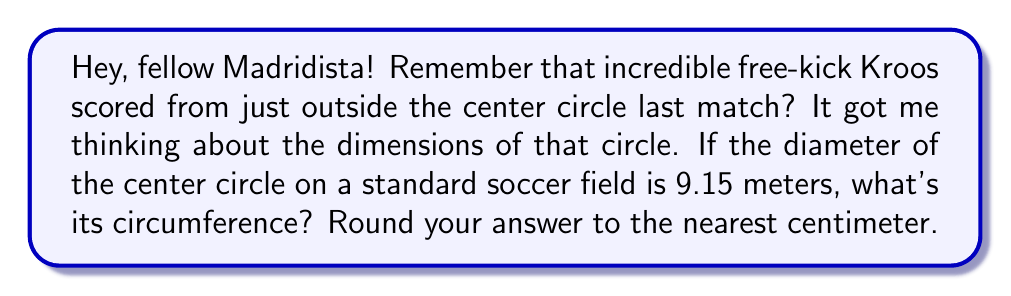Help me with this question. Let's approach this step-by-step:

1) The formula for the circumference of a circle is:

   $$C = \pi d$$

   where $C$ is the circumference and $d$ is the diameter.

2) We're given that the diameter is 9.15 meters.

3) Substituting this into our formula:

   $$C = \pi \times 9.15$$

4) $\pi$ is approximately 3.14159. Let's use this value for our calculation:

   $$C = 3.14159 \times 9.15$$

5) Multiplying:

   $$C = 28.745547 \text{ meters}$$

6) Rounding to the nearest centimeter (0.01 meters):

   $$C \approx 28.75 \text{ meters}$$

This means that if Kroos were to run along the edge of the center circle, he'd cover about 28.75 meters!
Answer: $28.75 \text{ meters}$ 